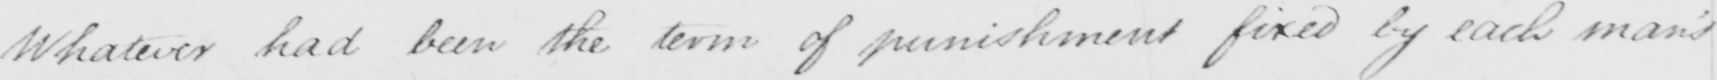Please provide the text content of this handwritten line. Whatever had been the term of punishment fixed by each man's 